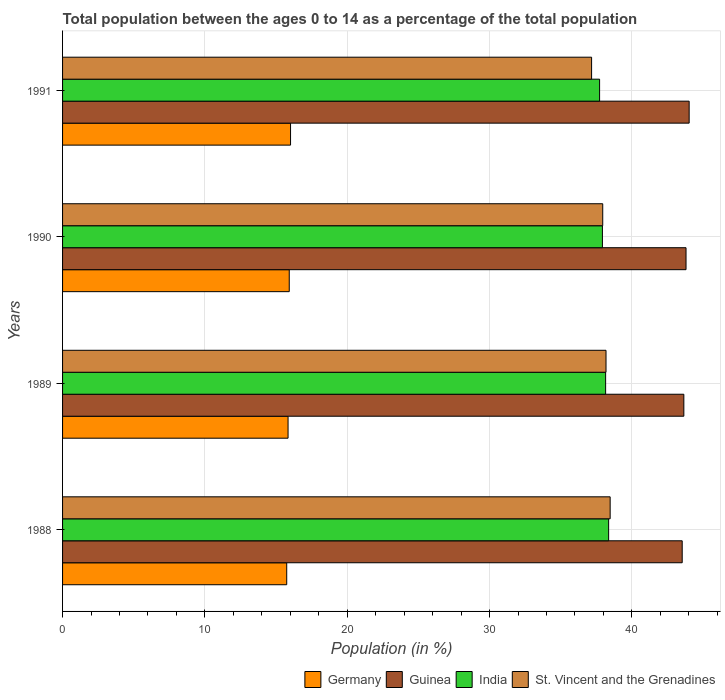How many groups of bars are there?
Make the answer very short. 4. Are the number of bars on each tick of the Y-axis equal?
Make the answer very short. Yes. How many bars are there on the 1st tick from the top?
Keep it short and to the point. 4. What is the label of the 1st group of bars from the top?
Give a very brief answer. 1991. In how many cases, is the number of bars for a given year not equal to the number of legend labels?
Offer a very short reply. 0. What is the percentage of the population ages 0 to 14 in Germany in 1988?
Keep it short and to the point. 15.75. Across all years, what is the maximum percentage of the population ages 0 to 14 in India?
Offer a terse response. 38.37. Across all years, what is the minimum percentage of the population ages 0 to 14 in St. Vincent and the Grenadines?
Ensure brevity in your answer.  37.17. In which year was the percentage of the population ages 0 to 14 in Guinea minimum?
Provide a succinct answer. 1988. What is the total percentage of the population ages 0 to 14 in Guinea in the graph?
Keep it short and to the point. 175.01. What is the difference between the percentage of the population ages 0 to 14 in Germany in 1988 and that in 1989?
Provide a succinct answer. -0.09. What is the difference between the percentage of the population ages 0 to 14 in Guinea in 1991 and the percentage of the population ages 0 to 14 in St. Vincent and the Grenadines in 1989?
Provide a short and direct response. 5.84. What is the average percentage of the population ages 0 to 14 in India per year?
Your answer should be very brief. 38.05. In the year 1989, what is the difference between the percentage of the population ages 0 to 14 in Germany and percentage of the population ages 0 to 14 in Guinea?
Offer a very short reply. -27.81. In how many years, is the percentage of the population ages 0 to 14 in India greater than 8 ?
Offer a very short reply. 4. What is the ratio of the percentage of the population ages 0 to 14 in St. Vincent and the Grenadines in 1988 to that in 1990?
Keep it short and to the point. 1.01. What is the difference between the highest and the second highest percentage of the population ages 0 to 14 in Germany?
Offer a terse response. 0.09. What is the difference between the highest and the lowest percentage of the population ages 0 to 14 in Guinea?
Make the answer very short. 0.49. In how many years, is the percentage of the population ages 0 to 14 in India greater than the average percentage of the population ages 0 to 14 in India taken over all years?
Your response must be concise. 2. What does the 1st bar from the top in 1988 represents?
Your response must be concise. St. Vincent and the Grenadines. What does the 2nd bar from the bottom in 1988 represents?
Make the answer very short. Guinea. How many bars are there?
Provide a succinct answer. 16. Are all the bars in the graph horizontal?
Provide a succinct answer. Yes. Are the values on the major ticks of X-axis written in scientific E-notation?
Make the answer very short. No. Where does the legend appear in the graph?
Your response must be concise. Bottom right. How many legend labels are there?
Give a very brief answer. 4. What is the title of the graph?
Provide a succinct answer. Total population between the ages 0 to 14 as a percentage of the total population. Does "Maldives" appear as one of the legend labels in the graph?
Make the answer very short. No. What is the label or title of the X-axis?
Offer a very short reply. Population (in %). What is the Population (in %) in Germany in 1988?
Keep it short and to the point. 15.75. What is the Population (in %) of Guinea in 1988?
Provide a short and direct response. 43.54. What is the Population (in %) in India in 1988?
Offer a terse response. 38.37. What is the Population (in %) of St. Vincent and the Grenadines in 1988?
Your answer should be compact. 38.47. What is the Population (in %) of Germany in 1989?
Ensure brevity in your answer.  15.84. What is the Population (in %) of Guinea in 1989?
Offer a very short reply. 43.65. What is the Population (in %) of India in 1989?
Your answer should be compact. 38.16. What is the Population (in %) of St. Vincent and the Grenadines in 1989?
Provide a short and direct response. 38.18. What is the Population (in %) of Germany in 1990?
Your response must be concise. 15.93. What is the Population (in %) in Guinea in 1990?
Your answer should be compact. 43.8. What is the Population (in %) in India in 1990?
Your response must be concise. 37.93. What is the Population (in %) of St. Vincent and the Grenadines in 1990?
Your response must be concise. 37.95. What is the Population (in %) in Germany in 1991?
Your answer should be very brief. 16.02. What is the Population (in %) in Guinea in 1991?
Keep it short and to the point. 44.02. What is the Population (in %) in India in 1991?
Ensure brevity in your answer.  37.73. What is the Population (in %) in St. Vincent and the Grenadines in 1991?
Keep it short and to the point. 37.17. Across all years, what is the maximum Population (in %) in Germany?
Keep it short and to the point. 16.02. Across all years, what is the maximum Population (in %) in Guinea?
Provide a short and direct response. 44.02. Across all years, what is the maximum Population (in %) in India?
Your response must be concise. 38.37. Across all years, what is the maximum Population (in %) in St. Vincent and the Grenadines?
Offer a terse response. 38.47. Across all years, what is the minimum Population (in %) in Germany?
Make the answer very short. 15.75. Across all years, what is the minimum Population (in %) in Guinea?
Offer a very short reply. 43.54. Across all years, what is the minimum Population (in %) of India?
Ensure brevity in your answer.  37.73. Across all years, what is the minimum Population (in %) in St. Vincent and the Grenadines?
Keep it short and to the point. 37.17. What is the total Population (in %) in Germany in the graph?
Ensure brevity in your answer.  63.54. What is the total Population (in %) in Guinea in the graph?
Provide a short and direct response. 175.01. What is the total Population (in %) in India in the graph?
Provide a short and direct response. 152.18. What is the total Population (in %) of St. Vincent and the Grenadines in the graph?
Provide a succinct answer. 151.78. What is the difference between the Population (in %) in Germany in 1988 and that in 1989?
Your answer should be compact. -0.09. What is the difference between the Population (in %) of Guinea in 1988 and that in 1989?
Offer a terse response. -0.12. What is the difference between the Population (in %) of India in 1988 and that in 1989?
Provide a short and direct response. 0.21. What is the difference between the Population (in %) of St. Vincent and the Grenadines in 1988 and that in 1989?
Keep it short and to the point. 0.29. What is the difference between the Population (in %) of Germany in 1988 and that in 1990?
Your answer should be compact. -0.18. What is the difference between the Population (in %) of Guinea in 1988 and that in 1990?
Your response must be concise. -0.27. What is the difference between the Population (in %) of India in 1988 and that in 1990?
Give a very brief answer. 0.44. What is the difference between the Population (in %) in St. Vincent and the Grenadines in 1988 and that in 1990?
Your response must be concise. 0.52. What is the difference between the Population (in %) of Germany in 1988 and that in 1991?
Give a very brief answer. -0.27. What is the difference between the Population (in %) in Guinea in 1988 and that in 1991?
Your answer should be compact. -0.49. What is the difference between the Population (in %) in India in 1988 and that in 1991?
Provide a succinct answer. 0.64. What is the difference between the Population (in %) in St. Vincent and the Grenadines in 1988 and that in 1991?
Your answer should be very brief. 1.3. What is the difference between the Population (in %) in Germany in 1989 and that in 1990?
Keep it short and to the point. -0.08. What is the difference between the Population (in %) in Guinea in 1989 and that in 1990?
Keep it short and to the point. -0.15. What is the difference between the Population (in %) of India in 1989 and that in 1990?
Your response must be concise. 0.23. What is the difference between the Population (in %) in St. Vincent and the Grenadines in 1989 and that in 1990?
Offer a very short reply. 0.23. What is the difference between the Population (in %) in Germany in 1989 and that in 1991?
Offer a very short reply. -0.17. What is the difference between the Population (in %) in Guinea in 1989 and that in 1991?
Your answer should be compact. -0.37. What is the difference between the Population (in %) in India in 1989 and that in 1991?
Give a very brief answer. 0.42. What is the difference between the Population (in %) in St. Vincent and the Grenadines in 1989 and that in 1991?
Ensure brevity in your answer.  1.01. What is the difference between the Population (in %) of Germany in 1990 and that in 1991?
Give a very brief answer. -0.09. What is the difference between the Population (in %) in Guinea in 1990 and that in 1991?
Offer a terse response. -0.22. What is the difference between the Population (in %) in India in 1990 and that in 1991?
Offer a very short reply. 0.2. What is the difference between the Population (in %) in St. Vincent and the Grenadines in 1990 and that in 1991?
Make the answer very short. 0.78. What is the difference between the Population (in %) of Germany in 1988 and the Population (in %) of Guinea in 1989?
Ensure brevity in your answer.  -27.9. What is the difference between the Population (in %) of Germany in 1988 and the Population (in %) of India in 1989?
Ensure brevity in your answer.  -22.41. What is the difference between the Population (in %) in Germany in 1988 and the Population (in %) in St. Vincent and the Grenadines in 1989?
Ensure brevity in your answer.  -22.43. What is the difference between the Population (in %) in Guinea in 1988 and the Population (in %) in India in 1989?
Ensure brevity in your answer.  5.38. What is the difference between the Population (in %) of Guinea in 1988 and the Population (in %) of St. Vincent and the Grenadines in 1989?
Make the answer very short. 5.35. What is the difference between the Population (in %) in India in 1988 and the Population (in %) in St. Vincent and the Grenadines in 1989?
Provide a short and direct response. 0.18. What is the difference between the Population (in %) in Germany in 1988 and the Population (in %) in Guinea in 1990?
Give a very brief answer. -28.05. What is the difference between the Population (in %) of Germany in 1988 and the Population (in %) of India in 1990?
Provide a succinct answer. -22.18. What is the difference between the Population (in %) in Germany in 1988 and the Population (in %) in St. Vincent and the Grenadines in 1990?
Your answer should be very brief. -22.2. What is the difference between the Population (in %) in Guinea in 1988 and the Population (in %) in India in 1990?
Provide a succinct answer. 5.61. What is the difference between the Population (in %) in Guinea in 1988 and the Population (in %) in St. Vincent and the Grenadines in 1990?
Ensure brevity in your answer.  5.58. What is the difference between the Population (in %) of India in 1988 and the Population (in %) of St. Vincent and the Grenadines in 1990?
Offer a very short reply. 0.42. What is the difference between the Population (in %) in Germany in 1988 and the Population (in %) in Guinea in 1991?
Provide a short and direct response. -28.27. What is the difference between the Population (in %) of Germany in 1988 and the Population (in %) of India in 1991?
Give a very brief answer. -21.98. What is the difference between the Population (in %) of Germany in 1988 and the Population (in %) of St. Vincent and the Grenadines in 1991?
Your response must be concise. -21.42. What is the difference between the Population (in %) of Guinea in 1988 and the Population (in %) of India in 1991?
Your answer should be compact. 5.8. What is the difference between the Population (in %) in Guinea in 1988 and the Population (in %) in St. Vincent and the Grenadines in 1991?
Give a very brief answer. 6.37. What is the difference between the Population (in %) of India in 1988 and the Population (in %) of St. Vincent and the Grenadines in 1991?
Provide a succinct answer. 1.2. What is the difference between the Population (in %) of Germany in 1989 and the Population (in %) of Guinea in 1990?
Make the answer very short. -27.96. What is the difference between the Population (in %) of Germany in 1989 and the Population (in %) of India in 1990?
Provide a short and direct response. -22.09. What is the difference between the Population (in %) in Germany in 1989 and the Population (in %) in St. Vincent and the Grenadines in 1990?
Your response must be concise. -22.11. What is the difference between the Population (in %) in Guinea in 1989 and the Population (in %) in India in 1990?
Offer a terse response. 5.72. What is the difference between the Population (in %) in Guinea in 1989 and the Population (in %) in St. Vincent and the Grenadines in 1990?
Provide a succinct answer. 5.7. What is the difference between the Population (in %) of India in 1989 and the Population (in %) of St. Vincent and the Grenadines in 1990?
Offer a terse response. 0.2. What is the difference between the Population (in %) in Germany in 1989 and the Population (in %) in Guinea in 1991?
Provide a succinct answer. -28.18. What is the difference between the Population (in %) of Germany in 1989 and the Population (in %) of India in 1991?
Keep it short and to the point. -21.89. What is the difference between the Population (in %) in Germany in 1989 and the Population (in %) in St. Vincent and the Grenadines in 1991?
Your response must be concise. -21.33. What is the difference between the Population (in %) of Guinea in 1989 and the Population (in %) of India in 1991?
Offer a terse response. 5.92. What is the difference between the Population (in %) in Guinea in 1989 and the Population (in %) in St. Vincent and the Grenadines in 1991?
Provide a short and direct response. 6.48. What is the difference between the Population (in %) of India in 1989 and the Population (in %) of St. Vincent and the Grenadines in 1991?
Keep it short and to the point. 0.99. What is the difference between the Population (in %) of Germany in 1990 and the Population (in %) of Guinea in 1991?
Offer a very short reply. -28.1. What is the difference between the Population (in %) in Germany in 1990 and the Population (in %) in India in 1991?
Keep it short and to the point. -21.8. What is the difference between the Population (in %) of Germany in 1990 and the Population (in %) of St. Vincent and the Grenadines in 1991?
Provide a succinct answer. -21.24. What is the difference between the Population (in %) of Guinea in 1990 and the Population (in %) of India in 1991?
Your answer should be compact. 6.07. What is the difference between the Population (in %) of Guinea in 1990 and the Population (in %) of St. Vincent and the Grenadines in 1991?
Your answer should be very brief. 6.64. What is the difference between the Population (in %) of India in 1990 and the Population (in %) of St. Vincent and the Grenadines in 1991?
Keep it short and to the point. 0.76. What is the average Population (in %) of Germany per year?
Provide a short and direct response. 15.88. What is the average Population (in %) in Guinea per year?
Your response must be concise. 43.75. What is the average Population (in %) of India per year?
Provide a succinct answer. 38.05. What is the average Population (in %) in St. Vincent and the Grenadines per year?
Give a very brief answer. 37.94. In the year 1988, what is the difference between the Population (in %) in Germany and Population (in %) in Guinea?
Keep it short and to the point. -27.79. In the year 1988, what is the difference between the Population (in %) in Germany and Population (in %) in India?
Provide a succinct answer. -22.62. In the year 1988, what is the difference between the Population (in %) of Germany and Population (in %) of St. Vincent and the Grenadines?
Provide a short and direct response. -22.72. In the year 1988, what is the difference between the Population (in %) of Guinea and Population (in %) of India?
Offer a terse response. 5.17. In the year 1988, what is the difference between the Population (in %) of Guinea and Population (in %) of St. Vincent and the Grenadines?
Provide a short and direct response. 5.06. In the year 1988, what is the difference between the Population (in %) of India and Population (in %) of St. Vincent and the Grenadines?
Offer a very short reply. -0.11. In the year 1989, what is the difference between the Population (in %) in Germany and Population (in %) in Guinea?
Keep it short and to the point. -27.81. In the year 1989, what is the difference between the Population (in %) in Germany and Population (in %) in India?
Ensure brevity in your answer.  -22.31. In the year 1989, what is the difference between the Population (in %) of Germany and Population (in %) of St. Vincent and the Grenadines?
Your answer should be compact. -22.34. In the year 1989, what is the difference between the Population (in %) in Guinea and Population (in %) in India?
Make the answer very short. 5.5. In the year 1989, what is the difference between the Population (in %) in Guinea and Population (in %) in St. Vincent and the Grenadines?
Give a very brief answer. 5.47. In the year 1989, what is the difference between the Population (in %) of India and Population (in %) of St. Vincent and the Grenadines?
Your answer should be compact. -0.03. In the year 1990, what is the difference between the Population (in %) of Germany and Population (in %) of Guinea?
Your answer should be compact. -27.88. In the year 1990, what is the difference between the Population (in %) in Germany and Population (in %) in India?
Your answer should be very brief. -22. In the year 1990, what is the difference between the Population (in %) in Germany and Population (in %) in St. Vincent and the Grenadines?
Your answer should be very brief. -22.02. In the year 1990, what is the difference between the Population (in %) of Guinea and Population (in %) of India?
Keep it short and to the point. 5.87. In the year 1990, what is the difference between the Population (in %) in Guinea and Population (in %) in St. Vincent and the Grenadines?
Provide a succinct answer. 5.85. In the year 1990, what is the difference between the Population (in %) of India and Population (in %) of St. Vincent and the Grenadines?
Offer a terse response. -0.02. In the year 1991, what is the difference between the Population (in %) of Germany and Population (in %) of Guinea?
Keep it short and to the point. -28.01. In the year 1991, what is the difference between the Population (in %) in Germany and Population (in %) in India?
Provide a short and direct response. -21.71. In the year 1991, what is the difference between the Population (in %) in Germany and Population (in %) in St. Vincent and the Grenadines?
Ensure brevity in your answer.  -21.15. In the year 1991, what is the difference between the Population (in %) of Guinea and Population (in %) of India?
Provide a succinct answer. 6.29. In the year 1991, what is the difference between the Population (in %) of Guinea and Population (in %) of St. Vincent and the Grenadines?
Offer a very short reply. 6.86. In the year 1991, what is the difference between the Population (in %) in India and Population (in %) in St. Vincent and the Grenadines?
Your answer should be very brief. 0.56. What is the ratio of the Population (in %) in Germany in 1988 to that in 1989?
Make the answer very short. 0.99. What is the ratio of the Population (in %) of India in 1988 to that in 1989?
Provide a short and direct response. 1.01. What is the ratio of the Population (in %) of St. Vincent and the Grenadines in 1988 to that in 1989?
Make the answer very short. 1.01. What is the ratio of the Population (in %) in Germany in 1988 to that in 1990?
Give a very brief answer. 0.99. What is the ratio of the Population (in %) of Guinea in 1988 to that in 1990?
Keep it short and to the point. 0.99. What is the ratio of the Population (in %) of India in 1988 to that in 1990?
Your response must be concise. 1.01. What is the ratio of the Population (in %) in St. Vincent and the Grenadines in 1988 to that in 1990?
Ensure brevity in your answer.  1.01. What is the ratio of the Population (in %) in Germany in 1988 to that in 1991?
Your answer should be compact. 0.98. What is the ratio of the Population (in %) in Guinea in 1988 to that in 1991?
Your answer should be very brief. 0.99. What is the ratio of the Population (in %) of India in 1988 to that in 1991?
Your answer should be very brief. 1.02. What is the ratio of the Population (in %) in St. Vincent and the Grenadines in 1988 to that in 1991?
Your response must be concise. 1.04. What is the ratio of the Population (in %) of St. Vincent and the Grenadines in 1989 to that in 1990?
Offer a terse response. 1.01. What is the ratio of the Population (in %) in Germany in 1989 to that in 1991?
Give a very brief answer. 0.99. What is the ratio of the Population (in %) of India in 1989 to that in 1991?
Your answer should be compact. 1.01. What is the ratio of the Population (in %) of St. Vincent and the Grenadines in 1989 to that in 1991?
Ensure brevity in your answer.  1.03. What is the ratio of the Population (in %) in Germany in 1990 to that in 1991?
Make the answer very short. 0.99. What is the ratio of the Population (in %) in Guinea in 1990 to that in 1991?
Your answer should be very brief. 0.99. What is the ratio of the Population (in %) of St. Vincent and the Grenadines in 1990 to that in 1991?
Provide a short and direct response. 1.02. What is the difference between the highest and the second highest Population (in %) in Germany?
Ensure brevity in your answer.  0.09. What is the difference between the highest and the second highest Population (in %) of Guinea?
Provide a succinct answer. 0.22. What is the difference between the highest and the second highest Population (in %) in India?
Your answer should be compact. 0.21. What is the difference between the highest and the second highest Population (in %) of St. Vincent and the Grenadines?
Provide a succinct answer. 0.29. What is the difference between the highest and the lowest Population (in %) in Germany?
Your response must be concise. 0.27. What is the difference between the highest and the lowest Population (in %) in Guinea?
Ensure brevity in your answer.  0.49. What is the difference between the highest and the lowest Population (in %) of India?
Offer a very short reply. 0.64. What is the difference between the highest and the lowest Population (in %) in St. Vincent and the Grenadines?
Ensure brevity in your answer.  1.3. 